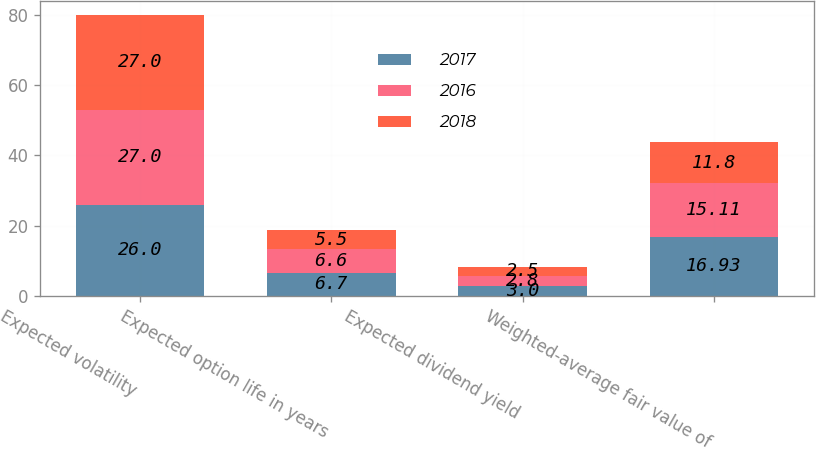<chart> <loc_0><loc_0><loc_500><loc_500><stacked_bar_chart><ecel><fcel>Expected volatility<fcel>Expected option life in years<fcel>Expected dividend yield<fcel>Weighted-average fair value of<nl><fcel>2017<fcel>26<fcel>6.7<fcel>3<fcel>16.93<nl><fcel>2016<fcel>27<fcel>6.6<fcel>2.8<fcel>15.11<nl><fcel>2018<fcel>27<fcel>5.5<fcel>2.5<fcel>11.8<nl></chart> 